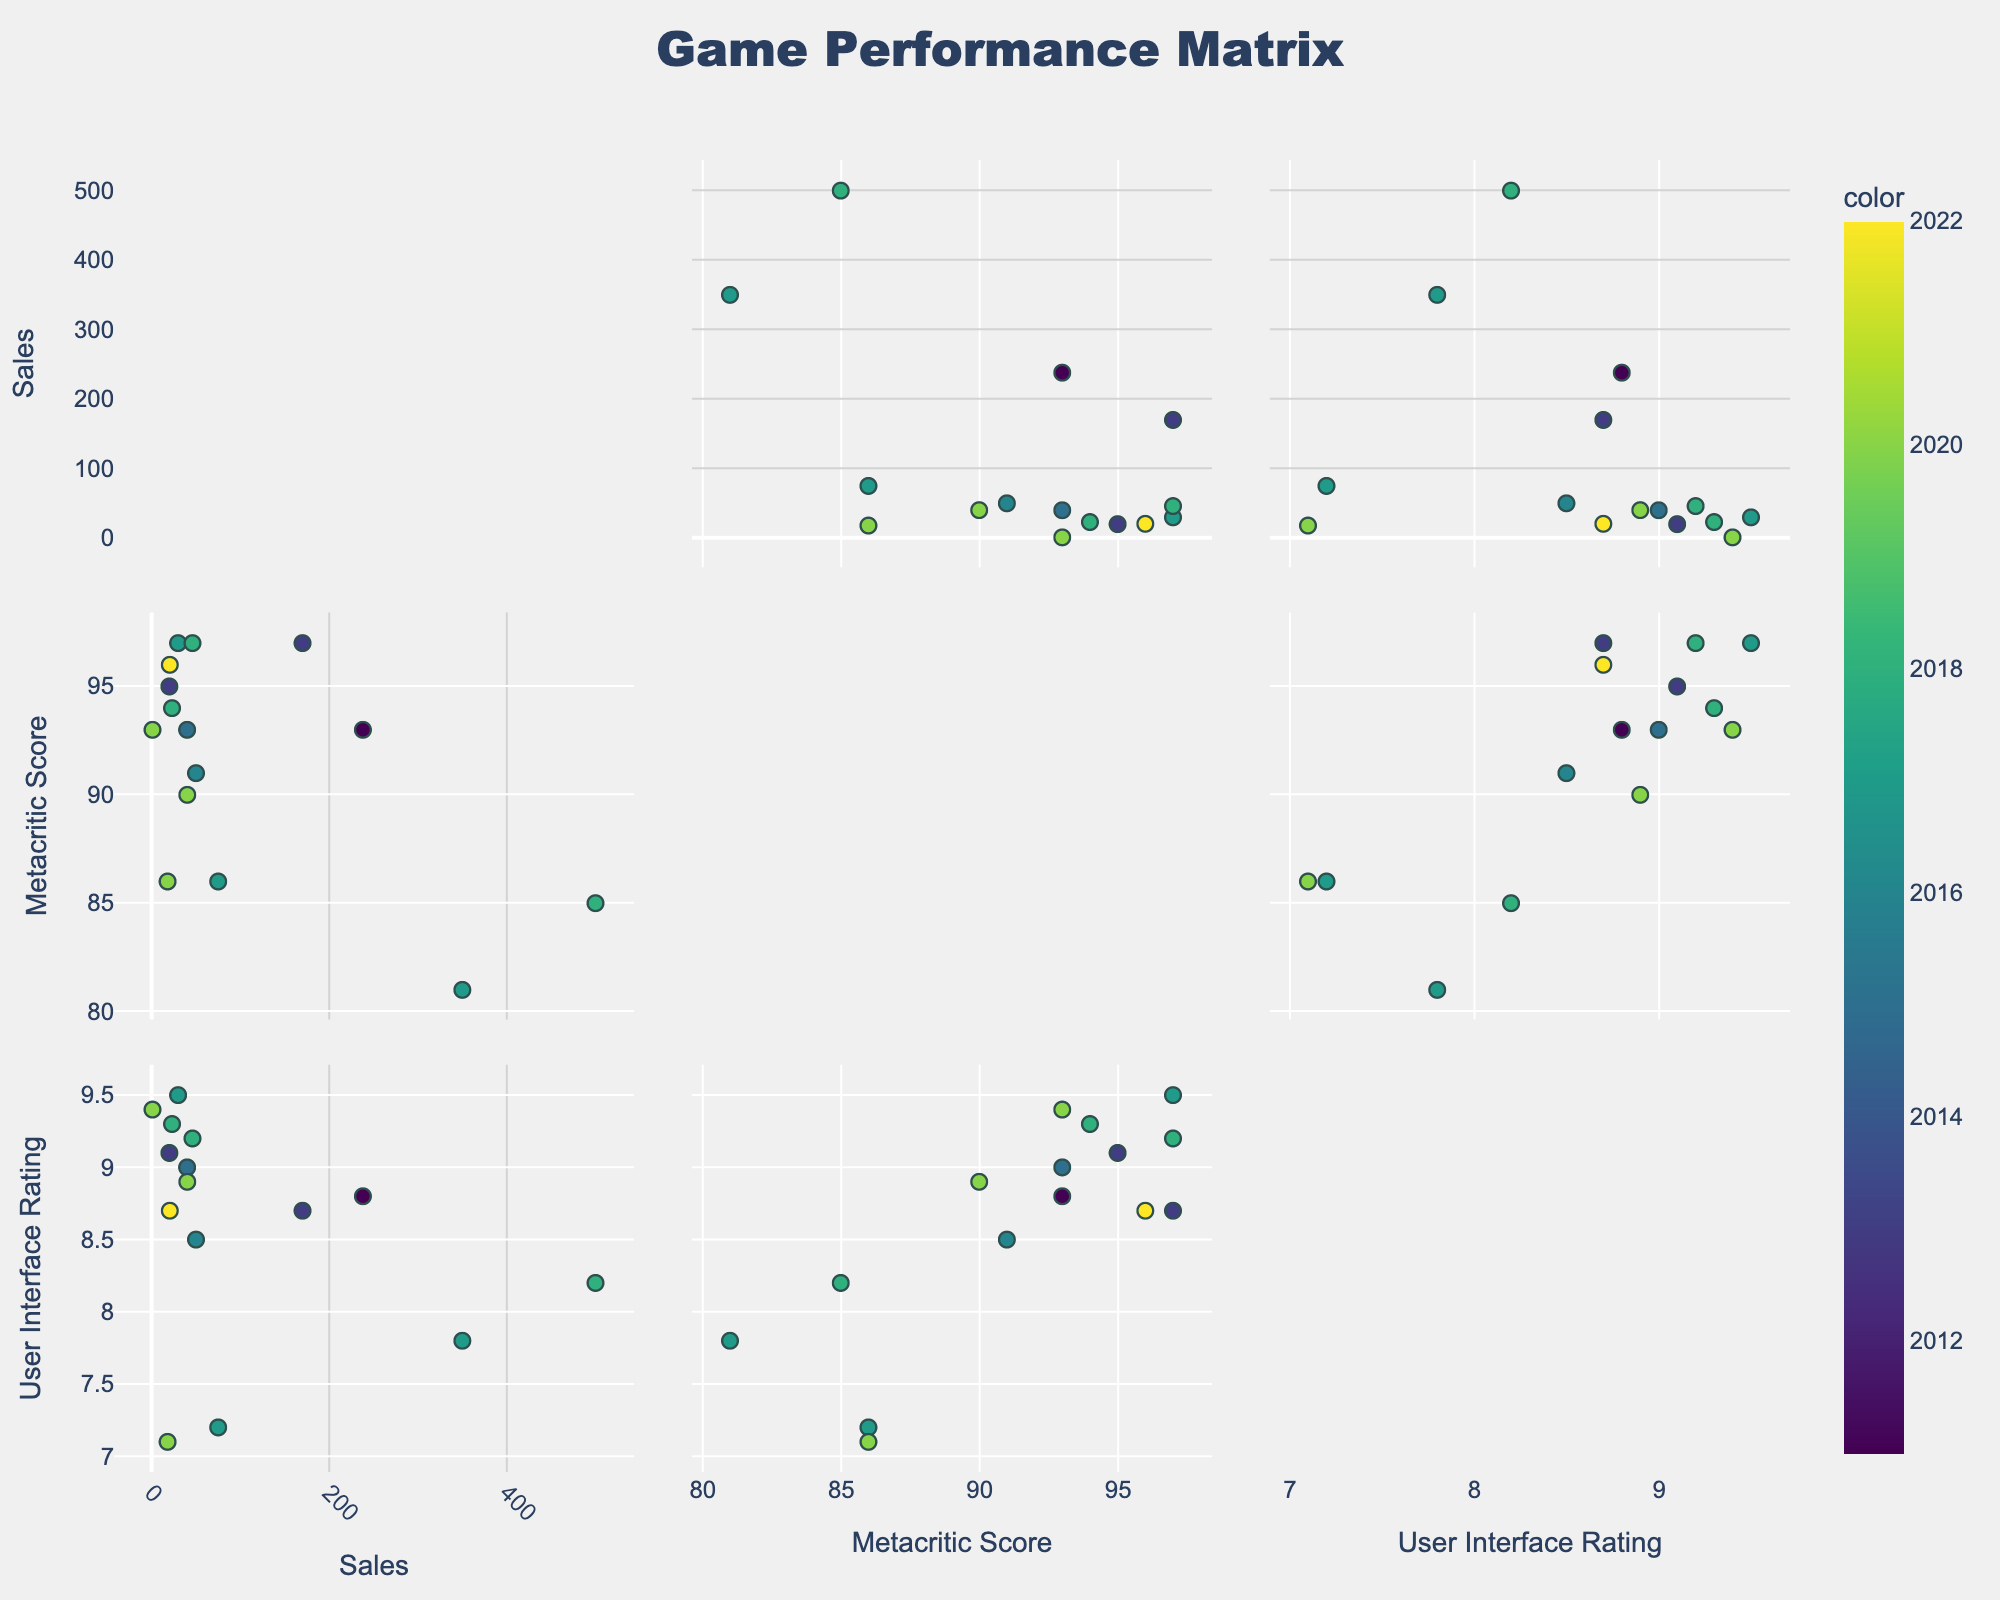What's the title of the figure? The title of a scatterplot matrix is typically displayed at the top center of the figure.
Answer: Game Performance Matrix How many games from the data are represented in the scatterplot matrix? Each game corresponds to a data point in the scatterplot matrix. There are 14 games listed in the provided data.
Answer: 14 Which game has the highest sales figure, and what is that figure? In the Sales (millions) vs. Game scatterplot, look for the data point farthest to the right. Hover over the point to see the game name and sales figure. The highest sales figure is for "Fortnite" at 350.0 million.
Answer: Fortnite, 350.0 million How does the 'Metacritic Score' relate to the 'Sales (millions)'? To answer this, look at the scatterplot comparing 'Metacritic Score' and 'Sales (millions)'. Notice the spread and distribution of data points to determine if there is any apparent correlation. There seems to be no clear linear relationship.
Answer: No clear relationship Which game has both high Metacritic Score and User Interface Rating with lower sales? Look for a data point that is high on both axes 'Metacritic Score' and 'User Interface Rating' but is relatively low on the 'Sales (millions)' axis. "Hades" meets these criteria.
Answer: Hades What's the average user interface rating for games released in 2017? Identify the points corresponding to 2017 in the scatterplot matrices. Extract their 'User Interface Rating' values: "The Legend of Zelda: Breath of the Wild" (9.5), "Fortnite" (7.8), and "PlayerUnknown's Battlegrounds" (7.2). Calculate the average: (9.5 + 7.8 + 7.2) / 3 = 8.17.
Answer: 8.17 Which data point represents the game 'Among Us,' and how is it characterized in terms of sales and user interface rating? Locate 'Among Us' in the hover information. It features very high sales and moderate user interface rating: 500.0 million sales and 8.2 user interface rating.
Answer: 500.0 million sales, 8.2 user interface rating Compare 'The Witcher 3: Wild Hunt' and 'Cyberpunk 2077'. Which has higher sales and how much higher is it? Find the positions of 'The Witcher 3: Wild Hunt' and 'Cyberpunk 2077' on the 'Sales (millions)' axis. 'The Witcher 3: Wild Hunt' has 40.0 million, while 'Cyberpunk 2077' has 18.0 million. The difference is 40.0 - 18.0 = 22.0 million.
Answer: The Witcher 3: Wild Hunt, 22.0 million higher Is there a game with a high user interface rating but a relatively low Metacritic Score? Look for a data point situated high on the 'User Interface Rating' axis but lower on the 'Metacritic Score' axis. "Cyberpunk 2077" stands out with 7.1 user interface rating but 86 Metacritic Score.
Answer: Cyberpunk 2077, Yes Which pair of games has the closest Metacritic Scores? Identify closely positioned points on the 'Metacritic Score' axis. 'The Legend of Zelda: Breath of the Wild,' 'Grand Theft Auto V,' and 'Red Dead Redemption 2' all have a Metacritic Score of 97.
Answer: The Legend of Zelda: Breath of the Wild and Grand Theft Auto V (both 97) Which year has the highest average sales figures? Using the hover information, identify all data points for each year, then calculate and compare the average sales figures for each year. 2018 has high sales figures contributed by "Red Dead Redemption 2" and "Among Us."
Answer: 2018 